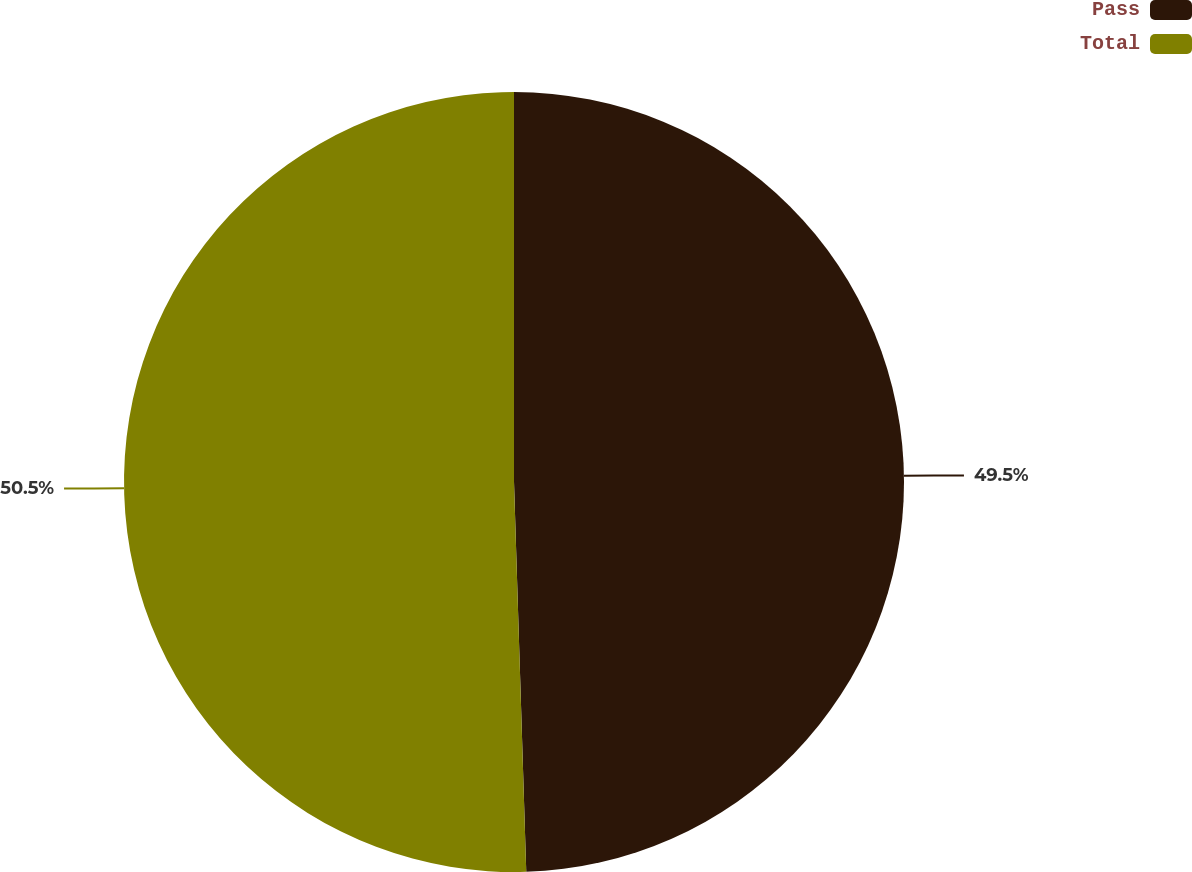Convert chart. <chart><loc_0><loc_0><loc_500><loc_500><pie_chart><fcel>Pass<fcel>Total<nl><fcel>49.5%<fcel>50.5%<nl></chart> 